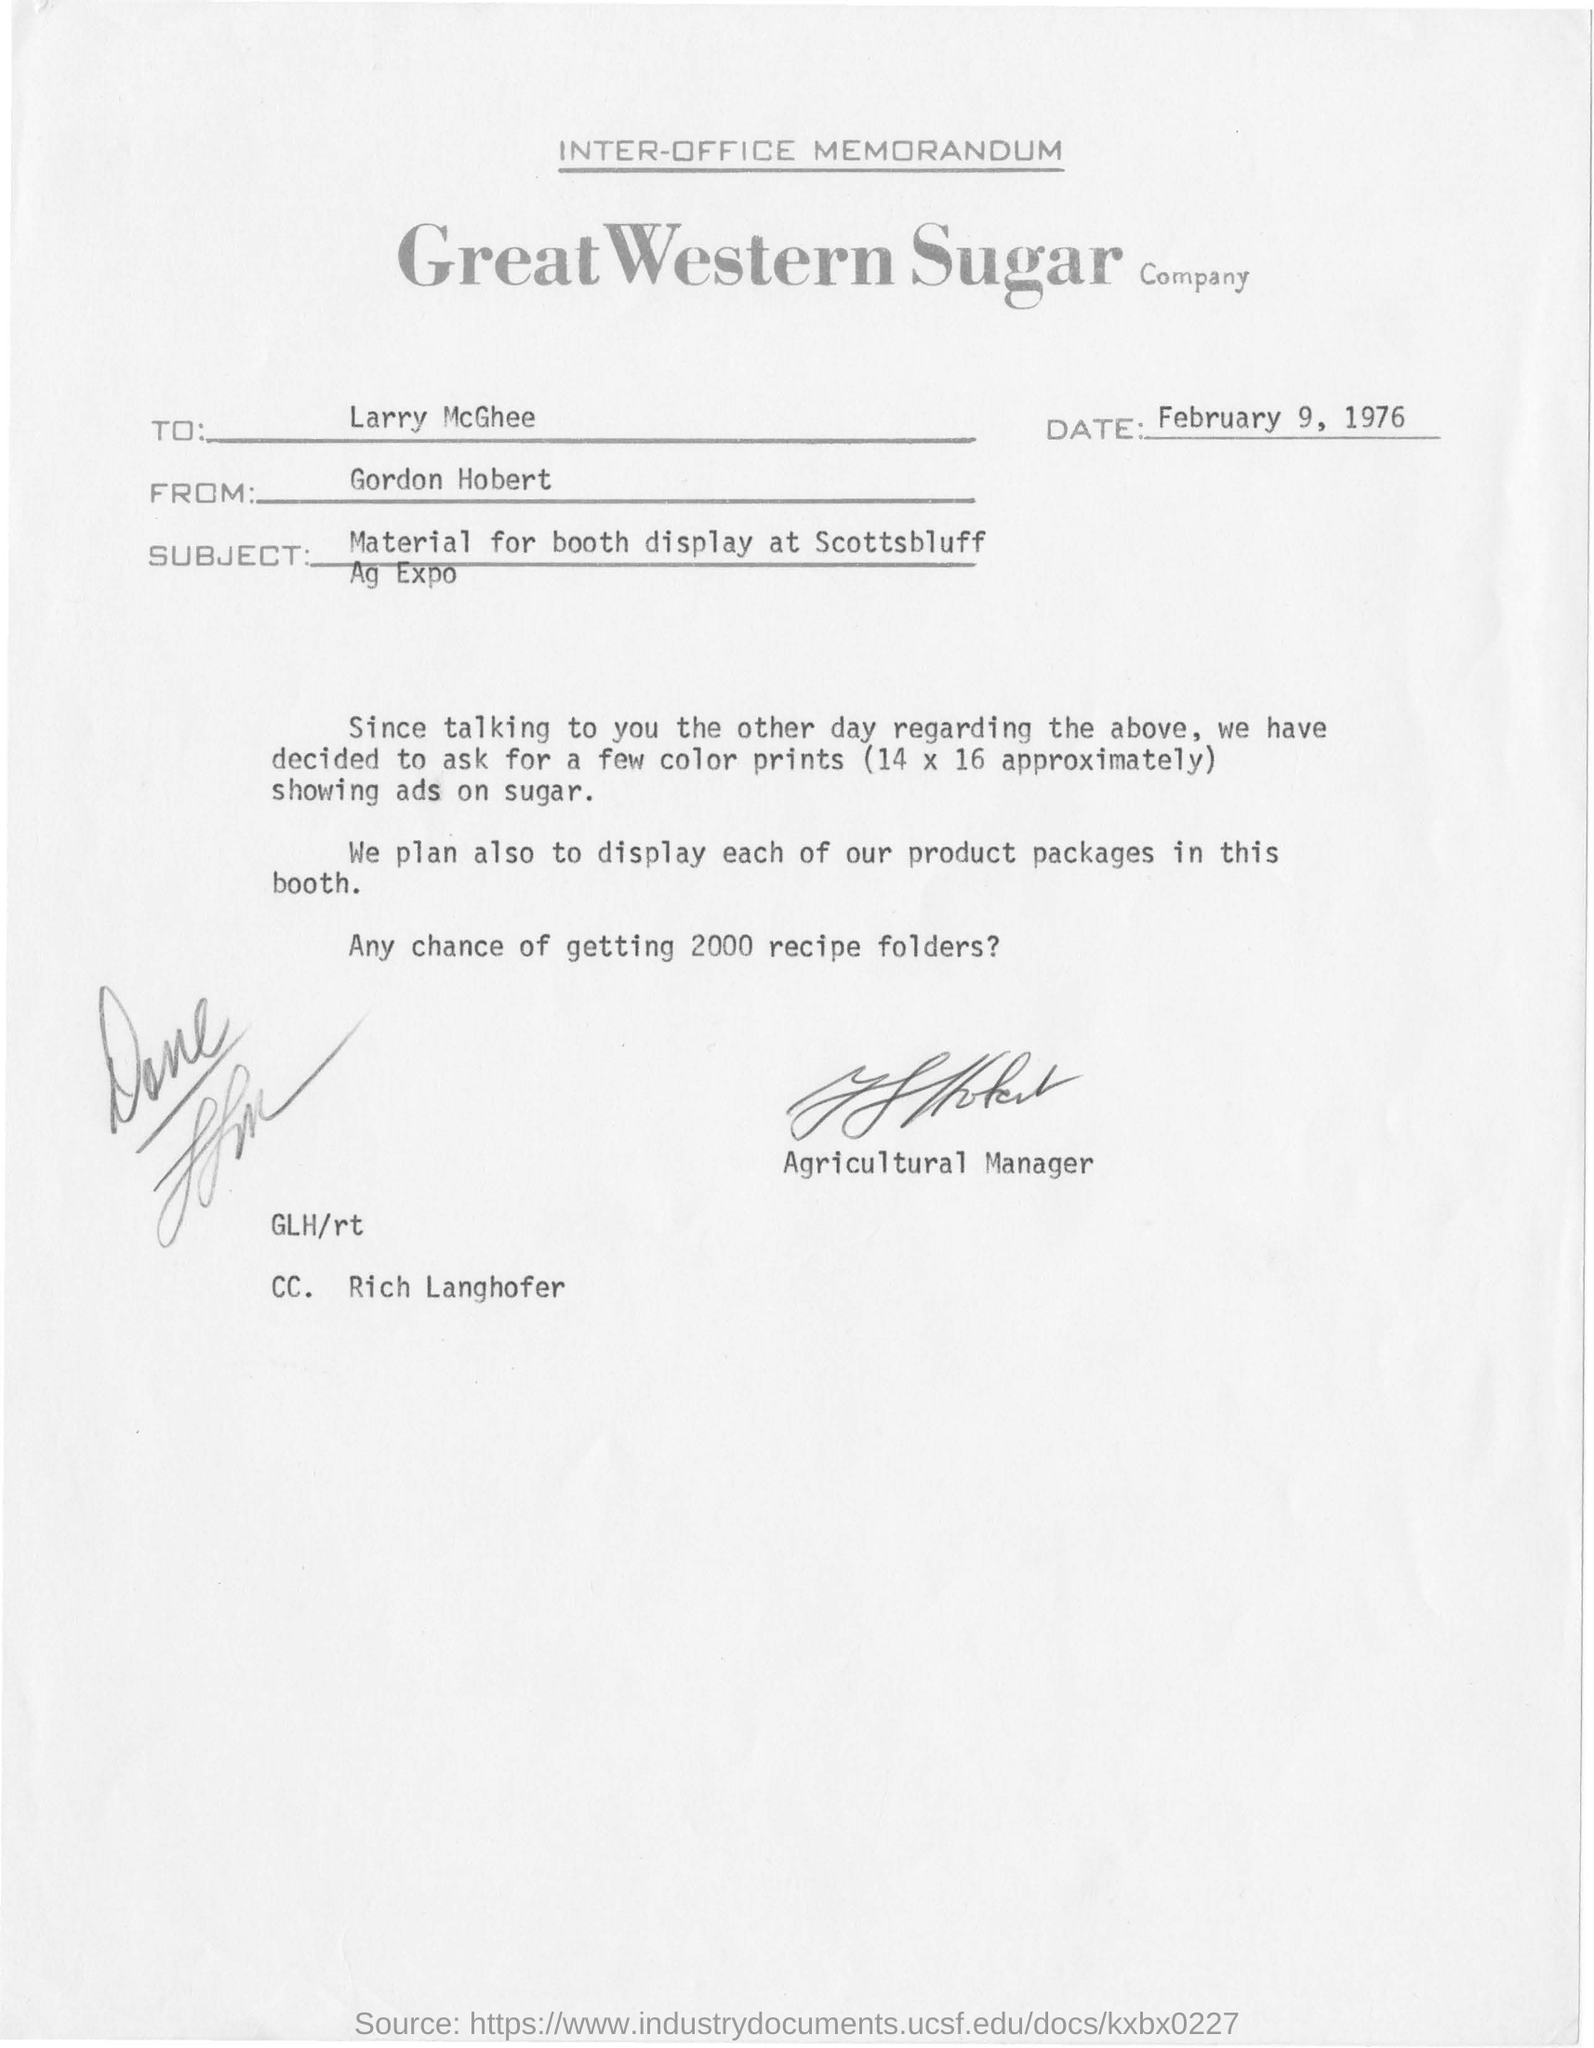From whom the memorandum is sent ?
Offer a terse response. Gordon Hobert. To Whom is this memorandum addressed to?
Offer a terse response. Larry McGhee. 